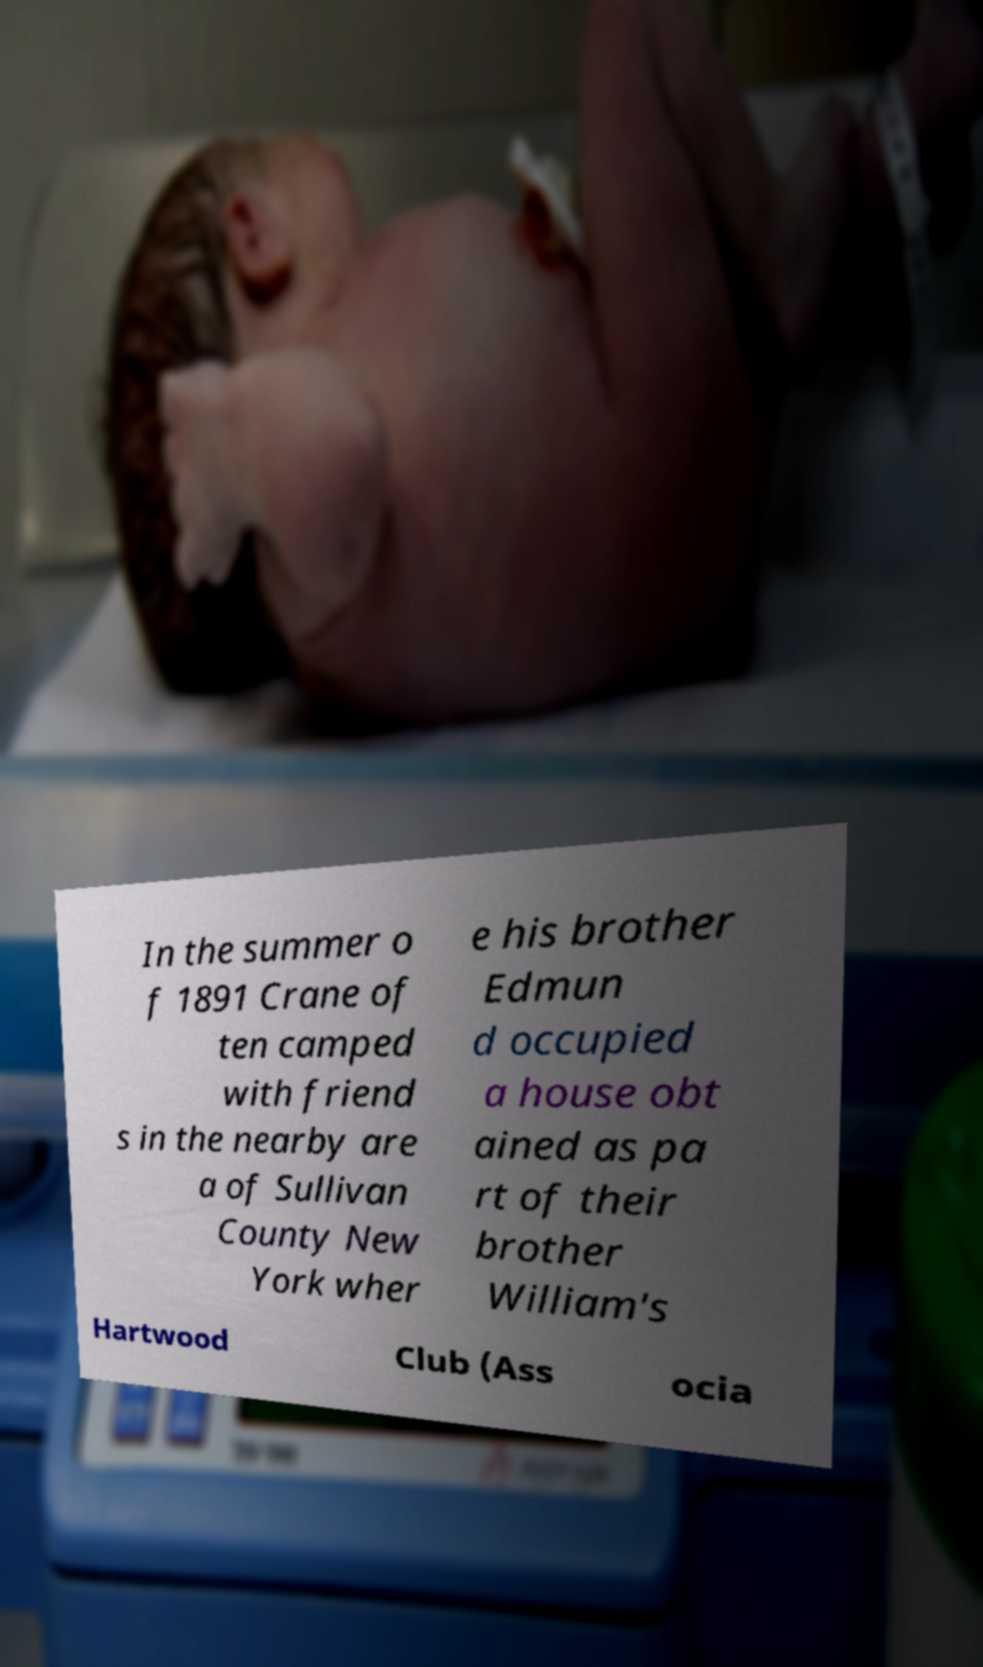I need the written content from this picture converted into text. Can you do that? In the summer o f 1891 Crane of ten camped with friend s in the nearby are a of Sullivan County New York wher e his brother Edmun d occupied a house obt ained as pa rt of their brother William's Hartwood Club (Ass ocia 